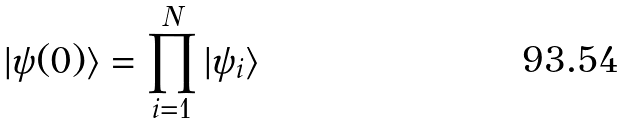Convert formula to latex. <formula><loc_0><loc_0><loc_500><loc_500>| \psi ( 0 ) \rangle = \prod _ { i = 1 } ^ { N } | \psi _ { i } \rangle</formula> 